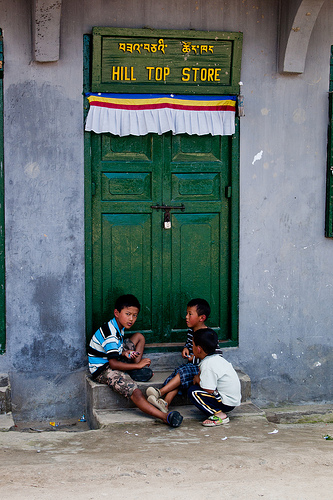<image>
Is there a boy on the ground? Yes. Looking at the image, I can see the boy is positioned on top of the ground, with the ground providing support. Is there a striped shirt next to the green door? Yes. The striped shirt is positioned adjacent to the green door, located nearby in the same general area. 